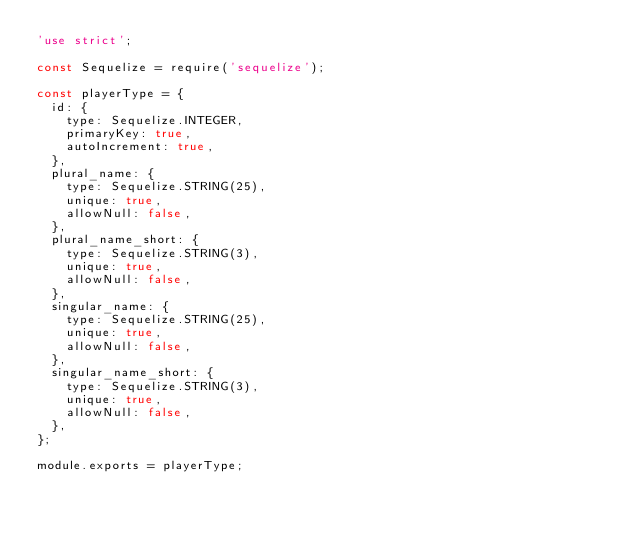<code> <loc_0><loc_0><loc_500><loc_500><_JavaScript_>'use strict';

const Sequelize = require('sequelize');

const playerType = {
  id: {
    type: Sequelize.INTEGER,
    primaryKey: true,
    autoIncrement: true,
  },
  plural_name: {
    type: Sequelize.STRING(25),
    unique: true,
    allowNull: false,
  },
  plural_name_short: {
    type: Sequelize.STRING(3),
    unique: true,
    allowNull: false,
  },
  singular_name: {
    type: Sequelize.STRING(25),
    unique: true,
    allowNull: false,
  },
  singular_name_short: {
    type: Sequelize.STRING(3),
    unique: true,
    allowNull: false,
  },
};

module.exports = playerType;
</code> 